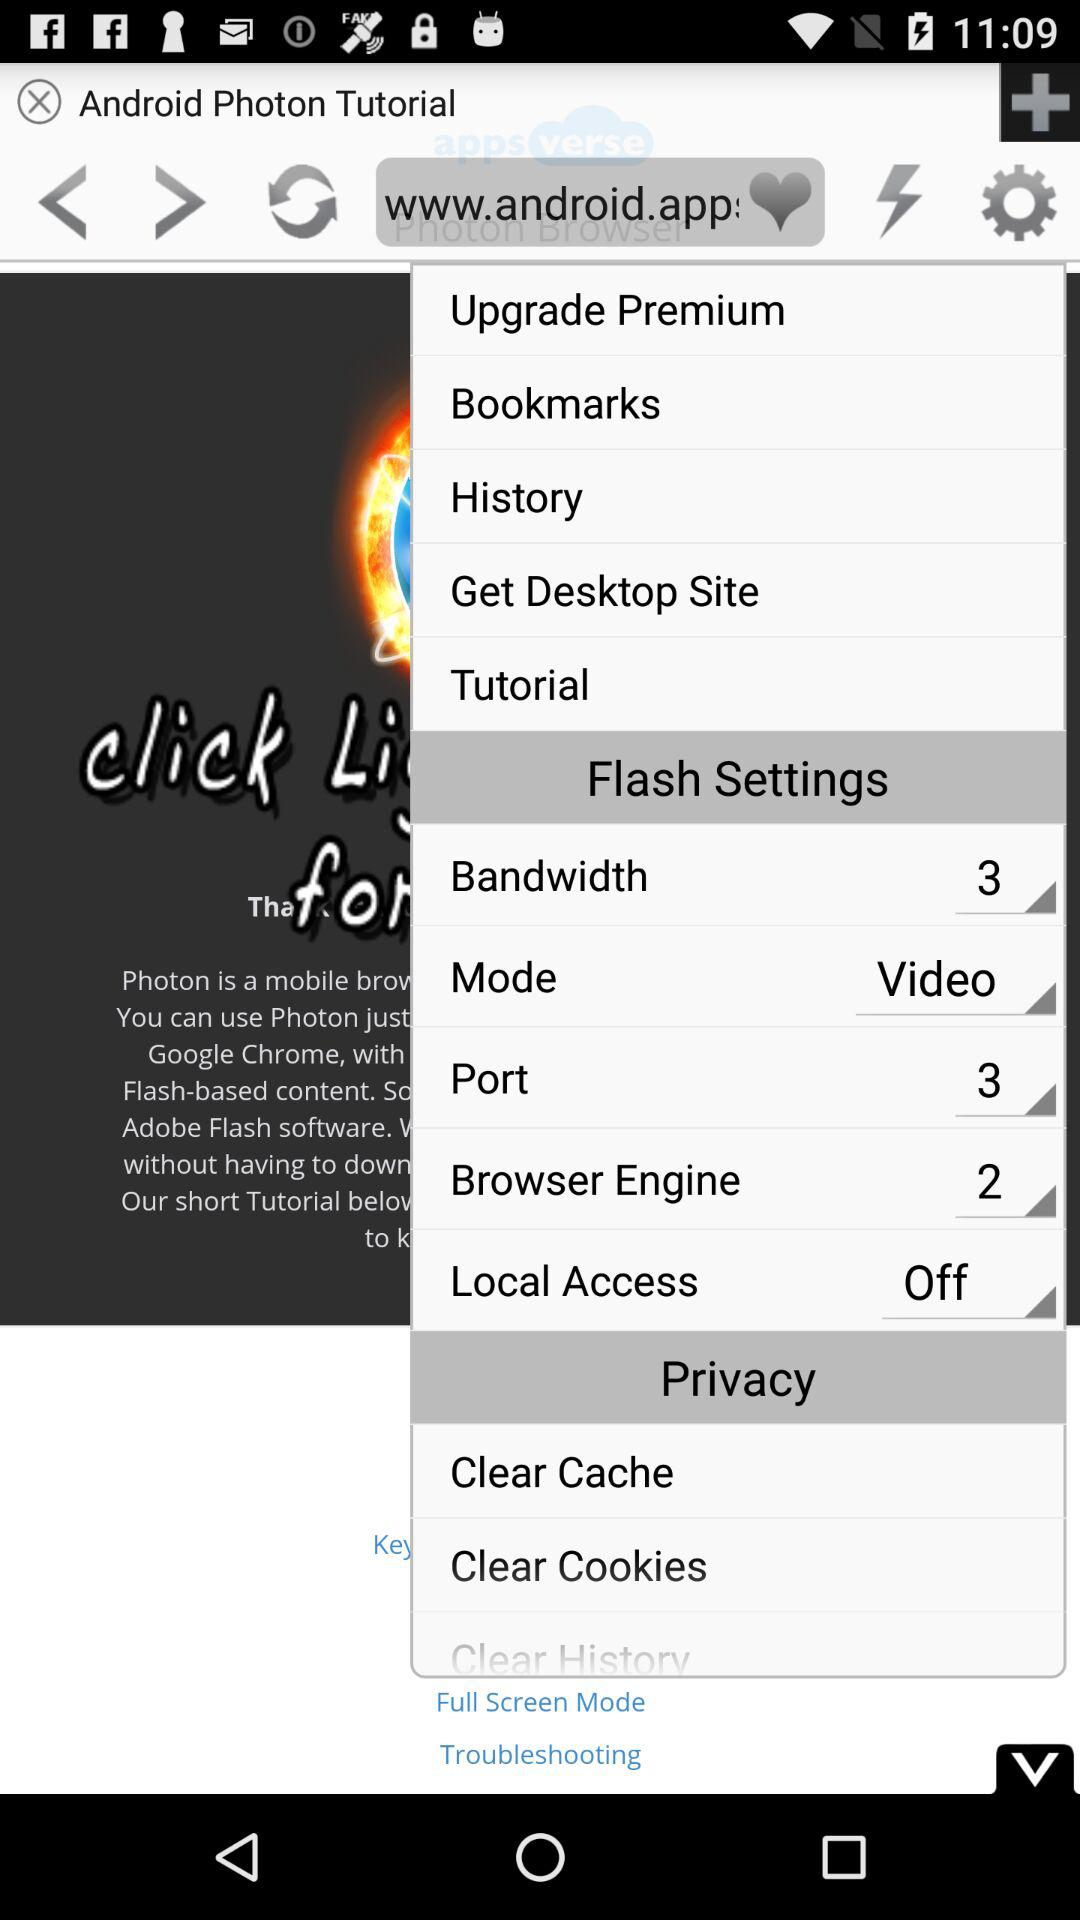How many numbers are in port? The number is 3. 